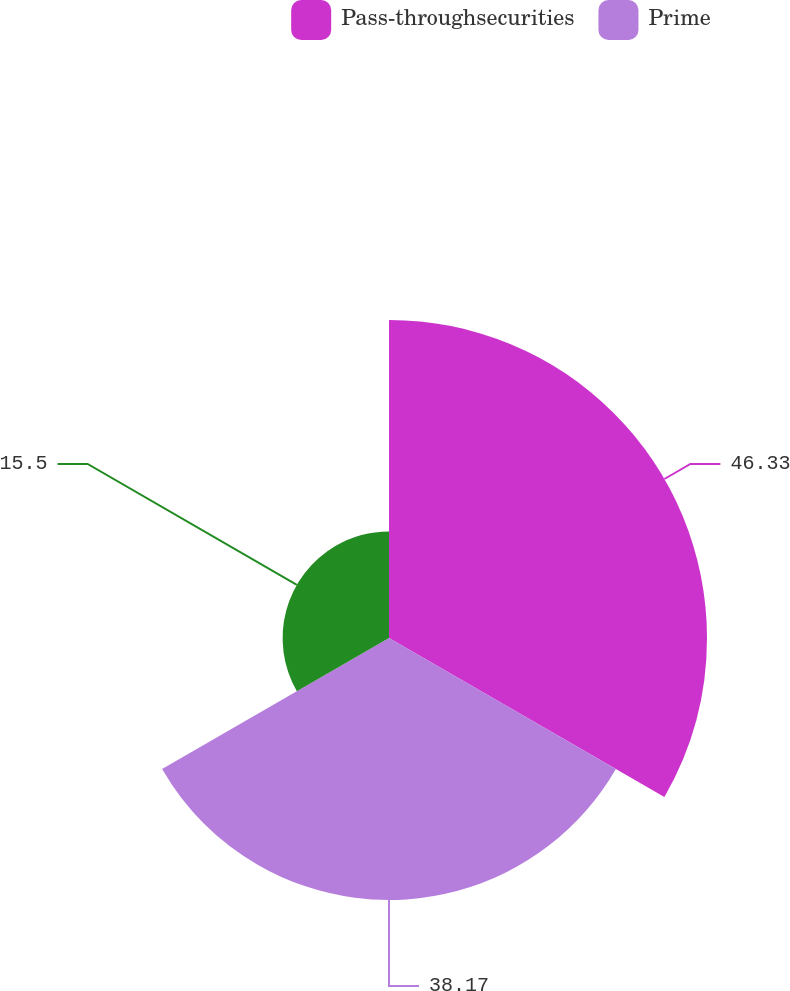<chart> <loc_0><loc_0><loc_500><loc_500><pie_chart><fcel>Pass-throughsecurities<fcel>Prime<fcel>Unnamed: 2<nl><fcel>46.33%<fcel>38.17%<fcel>15.5%<nl></chart> 